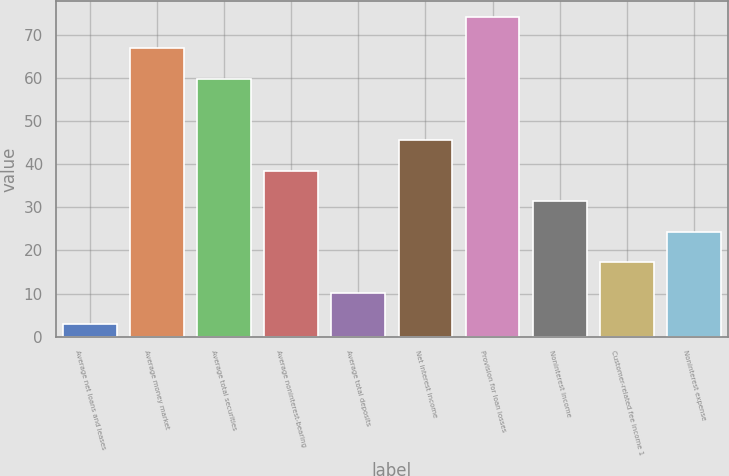<chart> <loc_0><loc_0><loc_500><loc_500><bar_chart><fcel>Average net loans and leases<fcel>Average money market<fcel>Average total securities<fcel>Average noninterest-bearing<fcel>Average total deposits<fcel>Net interest income<fcel>Provision for loan losses<fcel>Noninterest income<fcel>Customer-related fee income 1<fcel>Noninterest expense<nl><fcel>3<fcel>66.9<fcel>59.8<fcel>38.5<fcel>10.1<fcel>45.6<fcel>74<fcel>31.4<fcel>17.2<fcel>24.3<nl></chart> 